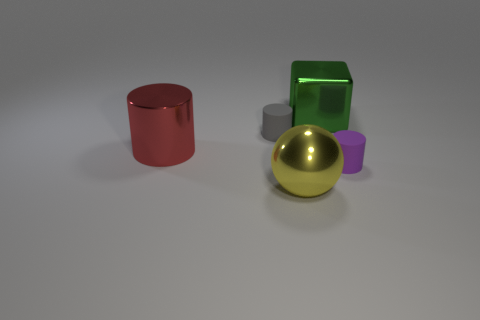Are there any other things that have the same size as the cube?
Offer a terse response. Yes. What number of other objects are there of the same material as the small purple cylinder?
Offer a terse response. 1. What number of rubber objects have the same size as the sphere?
Your answer should be very brief. 0. Do the ball that is right of the gray cylinder and the cylinder behind the big red metallic cylinder have the same material?
Offer a terse response. No. There is a large object that is behind the tiny thing that is left of the big metal cube; what is it made of?
Ensure brevity in your answer.  Metal. What is the large thing that is on the left side of the yellow sphere made of?
Your answer should be compact. Metal. What number of purple rubber things have the same shape as the tiny gray rubber object?
Your answer should be very brief. 1. What material is the large cube that is on the right side of the object left of the tiny rubber cylinder that is on the left side of the large yellow sphere?
Provide a succinct answer. Metal. Are there any tiny matte cylinders to the right of the yellow sphere?
Give a very brief answer. Yes. What is the shape of the red shiny thing that is the same size as the yellow metal object?
Provide a succinct answer. Cylinder. 